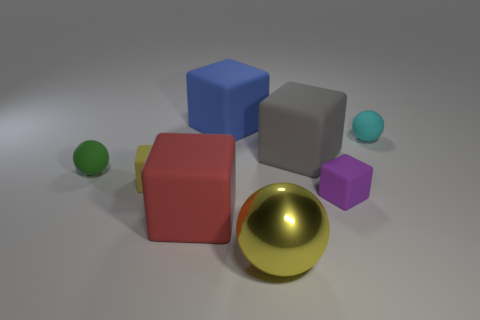What material is the big red cube right of the tiny matte thing that is to the left of the small cube behind the tiny purple block made of?
Make the answer very short. Rubber. What is the material of the small thing that is on the right side of the tiny purple block?
Make the answer very short. Rubber. Is there a red metallic cylinder of the same size as the gray block?
Make the answer very short. No. Do the small rubber block that is to the left of the big metal sphere and the shiny thing have the same color?
Your answer should be very brief. Yes. What number of brown things are big cylinders or big spheres?
Offer a very short reply. 0. How many small objects have the same color as the metal sphere?
Provide a succinct answer. 1. Do the green object and the blue cube have the same material?
Your answer should be very brief. Yes. How many small things are to the left of the large gray matte thing that is in front of the small cyan matte ball?
Your answer should be very brief. 2. Do the yellow metallic sphere and the cyan thing have the same size?
Your response must be concise. No. What number of cyan spheres have the same material as the purple object?
Your answer should be very brief. 1. 